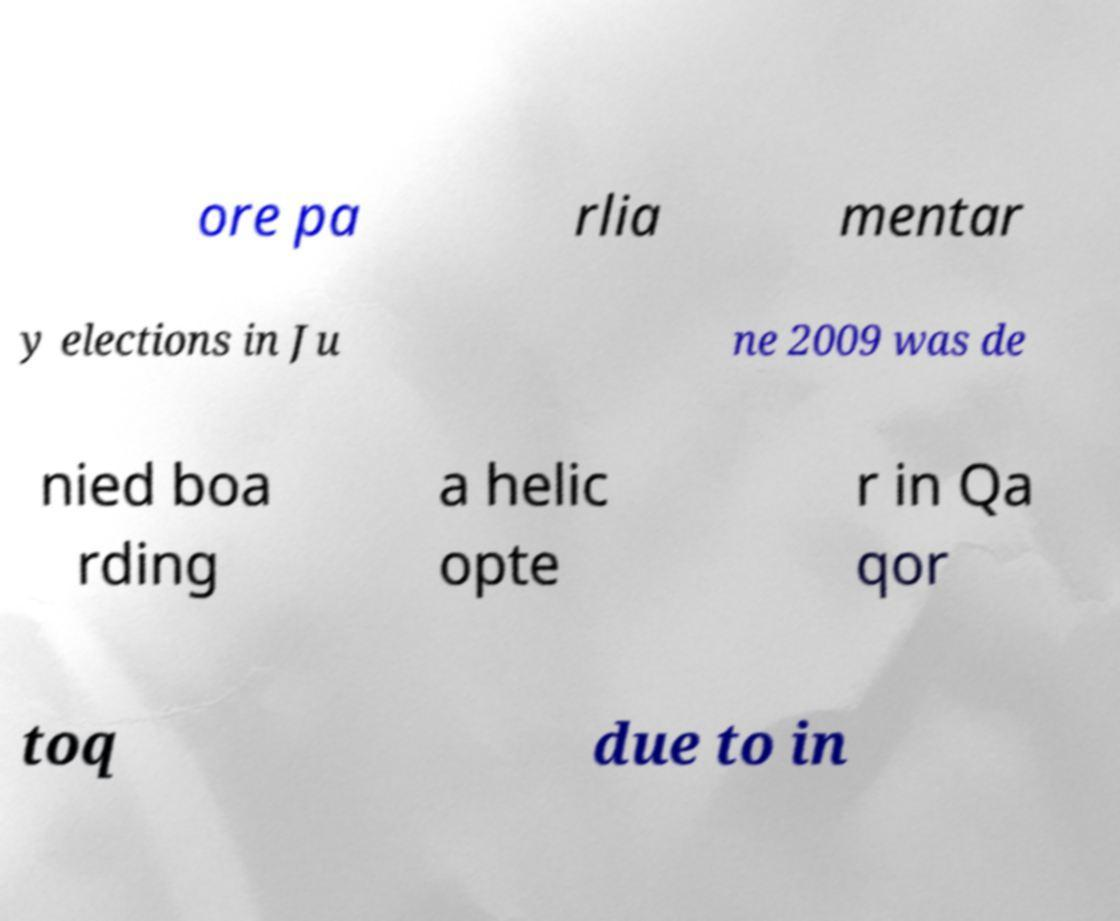Can you accurately transcribe the text from the provided image for me? ore pa rlia mentar y elections in Ju ne 2009 was de nied boa rding a helic opte r in Qa qor toq due to in 